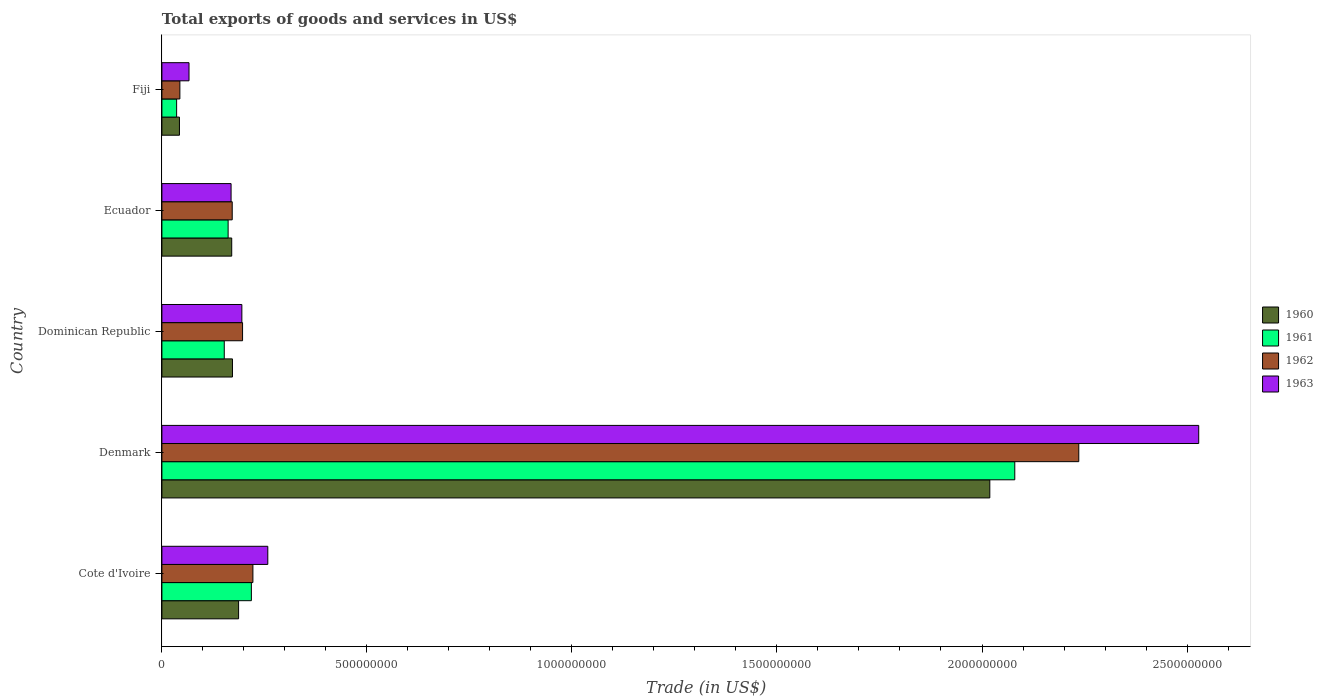What is the label of the 1st group of bars from the top?
Offer a terse response. Fiji. In how many cases, is the number of bars for a given country not equal to the number of legend labels?
Offer a terse response. 0. What is the total exports of goods and services in 1961 in Ecuador?
Your answer should be very brief. 1.61e+08. Across all countries, what is the maximum total exports of goods and services in 1962?
Give a very brief answer. 2.24e+09. Across all countries, what is the minimum total exports of goods and services in 1963?
Provide a short and direct response. 6.61e+07. In which country was the total exports of goods and services in 1961 maximum?
Your response must be concise. Denmark. In which country was the total exports of goods and services in 1960 minimum?
Make the answer very short. Fiji. What is the total total exports of goods and services in 1962 in the graph?
Offer a very short reply. 2.87e+09. What is the difference between the total exports of goods and services in 1963 in Denmark and that in Ecuador?
Keep it short and to the point. 2.36e+09. What is the difference between the total exports of goods and services in 1960 in Fiji and the total exports of goods and services in 1962 in Ecuador?
Provide a short and direct response. -1.29e+08. What is the average total exports of goods and services in 1960 per country?
Your answer should be compact. 5.18e+08. What is the difference between the total exports of goods and services in 1963 and total exports of goods and services in 1962 in Ecuador?
Give a very brief answer. -2.79e+06. In how many countries, is the total exports of goods and services in 1962 greater than 1200000000 US$?
Provide a short and direct response. 1. What is the ratio of the total exports of goods and services in 1960 in Denmark to that in Ecuador?
Make the answer very short. 11.86. Is the total exports of goods and services in 1963 in Cote d'Ivoire less than that in Dominican Republic?
Give a very brief answer. No. Is the difference between the total exports of goods and services in 1963 in Ecuador and Fiji greater than the difference between the total exports of goods and services in 1962 in Ecuador and Fiji?
Your answer should be very brief. No. What is the difference between the highest and the second highest total exports of goods and services in 1960?
Offer a terse response. 1.83e+09. What is the difference between the highest and the lowest total exports of goods and services in 1961?
Your answer should be very brief. 2.04e+09. What does the 3rd bar from the top in Dominican Republic represents?
Provide a succinct answer. 1961. Is it the case that in every country, the sum of the total exports of goods and services in 1963 and total exports of goods and services in 1961 is greater than the total exports of goods and services in 1960?
Ensure brevity in your answer.  Yes. What is the difference between two consecutive major ticks on the X-axis?
Your response must be concise. 5.00e+08. How many legend labels are there?
Keep it short and to the point. 4. How are the legend labels stacked?
Offer a terse response. Vertical. What is the title of the graph?
Your answer should be compact. Total exports of goods and services in US$. What is the label or title of the X-axis?
Ensure brevity in your answer.  Trade (in US$). What is the label or title of the Y-axis?
Your answer should be compact. Country. What is the Trade (in US$) of 1960 in Cote d'Ivoire?
Offer a very short reply. 1.87e+08. What is the Trade (in US$) in 1961 in Cote d'Ivoire?
Your answer should be compact. 2.18e+08. What is the Trade (in US$) in 1962 in Cote d'Ivoire?
Keep it short and to the point. 2.22e+08. What is the Trade (in US$) of 1963 in Cote d'Ivoire?
Offer a terse response. 2.58e+08. What is the Trade (in US$) in 1960 in Denmark?
Provide a short and direct response. 2.02e+09. What is the Trade (in US$) of 1961 in Denmark?
Ensure brevity in your answer.  2.08e+09. What is the Trade (in US$) in 1962 in Denmark?
Your answer should be compact. 2.24e+09. What is the Trade (in US$) in 1963 in Denmark?
Provide a short and direct response. 2.53e+09. What is the Trade (in US$) in 1960 in Dominican Republic?
Offer a terse response. 1.72e+08. What is the Trade (in US$) of 1961 in Dominican Republic?
Provide a short and direct response. 1.52e+08. What is the Trade (in US$) in 1962 in Dominican Republic?
Keep it short and to the point. 1.97e+08. What is the Trade (in US$) in 1963 in Dominican Republic?
Your answer should be compact. 1.95e+08. What is the Trade (in US$) of 1960 in Ecuador?
Make the answer very short. 1.70e+08. What is the Trade (in US$) of 1961 in Ecuador?
Offer a very short reply. 1.61e+08. What is the Trade (in US$) of 1962 in Ecuador?
Your response must be concise. 1.71e+08. What is the Trade (in US$) of 1963 in Ecuador?
Provide a short and direct response. 1.69e+08. What is the Trade (in US$) of 1960 in Fiji?
Your response must be concise. 4.28e+07. What is the Trade (in US$) in 1961 in Fiji?
Provide a succinct answer. 3.59e+07. What is the Trade (in US$) in 1962 in Fiji?
Give a very brief answer. 4.38e+07. What is the Trade (in US$) of 1963 in Fiji?
Your response must be concise. 6.61e+07. Across all countries, what is the maximum Trade (in US$) of 1960?
Give a very brief answer. 2.02e+09. Across all countries, what is the maximum Trade (in US$) in 1961?
Your response must be concise. 2.08e+09. Across all countries, what is the maximum Trade (in US$) of 1962?
Offer a very short reply. 2.24e+09. Across all countries, what is the maximum Trade (in US$) of 1963?
Provide a short and direct response. 2.53e+09. Across all countries, what is the minimum Trade (in US$) of 1960?
Provide a succinct answer. 4.28e+07. Across all countries, what is the minimum Trade (in US$) in 1961?
Make the answer very short. 3.59e+07. Across all countries, what is the minimum Trade (in US$) in 1962?
Keep it short and to the point. 4.38e+07. Across all countries, what is the minimum Trade (in US$) in 1963?
Make the answer very short. 6.61e+07. What is the total Trade (in US$) of 1960 in the graph?
Your response must be concise. 2.59e+09. What is the total Trade (in US$) in 1961 in the graph?
Give a very brief answer. 2.65e+09. What is the total Trade (in US$) in 1962 in the graph?
Provide a short and direct response. 2.87e+09. What is the total Trade (in US$) of 1963 in the graph?
Your answer should be compact. 3.22e+09. What is the difference between the Trade (in US$) in 1960 in Cote d'Ivoire and that in Denmark?
Make the answer very short. -1.83e+09. What is the difference between the Trade (in US$) in 1961 in Cote d'Ivoire and that in Denmark?
Provide a succinct answer. -1.86e+09. What is the difference between the Trade (in US$) of 1962 in Cote d'Ivoire and that in Denmark?
Your answer should be compact. -2.01e+09. What is the difference between the Trade (in US$) in 1963 in Cote d'Ivoire and that in Denmark?
Ensure brevity in your answer.  -2.27e+09. What is the difference between the Trade (in US$) of 1960 in Cote d'Ivoire and that in Dominican Republic?
Offer a terse response. 1.49e+07. What is the difference between the Trade (in US$) of 1961 in Cote d'Ivoire and that in Dominican Republic?
Keep it short and to the point. 6.61e+07. What is the difference between the Trade (in US$) in 1962 in Cote d'Ivoire and that in Dominican Republic?
Your answer should be compact. 2.52e+07. What is the difference between the Trade (in US$) of 1963 in Cote d'Ivoire and that in Dominican Republic?
Provide a short and direct response. 6.33e+07. What is the difference between the Trade (in US$) in 1960 in Cote d'Ivoire and that in Ecuador?
Offer a very short reply. 1.68e+07. What is the difference between the Trade (in US$) of 1961 in Cote d'Ivoire and that in Ecuador?
Provide a short and direct response. 5.67e+07. What is the difference between the Trade (in US$) in 1962 in Cote d'Ivoire and that in Ecuador?
Make the answer very short. 5.04e+07. What is the difference between the Trade (in US$) of 1963 in Cote d'Ivoire and that in Ecuador?
Your answer should be very brief. 8.96e+07. What is the difference between the Trade (in US$) of 1960 in Cote d'Ivoire and that in Fiji?
Give a very brief answer. 1.44e+08. What is the difference between the Trade (in US$) of 1961 in Cote d'Ivoire and that in Fiji?
Ensure brevity in your answer.  1.82e+08. What is the difference between the Trade (in US$) in 1962 in Cote d'Ivoire and that in Fiji?
Your response must be concise. 1.78e+08. What is the difference between the Trade (in US$) of 1963 in Cote d'Ivoire and that in Fiji?
Offer a very short reply. 1.92e+08. What is the difference between the Trade (in US$) of 1960 in Denmark and that in Dominican Republic?
Your answer should be very brief. 1.85e+09. What is the difference between the Trade (in US$) in 1961 in Denmark and that in Dominican Republic?
Offer a terse response. 1.93e+09. What is the difference between the Trade (in US$) of 1962 in Denmark and that in Dominican Republic?
Make the answer very short. 2.04e+09. What is the difference between the Trade (in US$) in 1963 in Denmark and that in Dominican Republic?
Provide a short and direct response. 2.33e+09. What is the difference between the Trade (in US$) in 1960 in Denmark and that in Ecuador?
Keep it short and to the point. 1.85e+09. What is the difference between the Trade (in US$) of 1961 in Denmark and that in Ecuador?
Your answer should be very brief. 1.92e+09. What is the difference between the Trade (in US$) in 1962 in Denmark and that in Ecuador?
Give a very brief answer. 2.06e+09. What is the difference between the Trade (in US$) of 1963 in Denmark and that in Ecuador?
Make the answer very short. 2.36e+09. What is the difference between the Trade (in US$) of 1960 in Denmark and that in Fiji?
Your answer should be compact. 1.98e+09. What is the difference between the Trade (in US$) of 1961 in Denmark and that in Fiji?
Provide a succinct answer. 2.04e+09. What is the difference between the Trade (in US$) in 1962 in Denmark and that in Fiji?
Your answer should be very brief. 2.19e+09. What is the difference between the Trade (in US$) in 1963 in Denmark and that in Fiji?
Ensure brevity in your answer.  2.46e+09. What is the difference between the Trade (in US$) of 1960 in Dominican Republic and that in Ecuador?
Ensure brevity in your answer.  1.84e+06. What is the difference between the Trade (in US$) in 1961 in Dominican Republic and that in Ecuador?
Offer a terse response. -9.39e+06. What is the difference between the Trade (in US$) in 1962 in Dominican Republic and that in Ecuador?
Make the answer very short. 2.52e+07. What is the difference between the Trade (in US$) in 1963 in Dominican Republic and that in Ecuador?
Give a very brief answer. 2.63e+07. What is the difference between the Trade (in US$) in 1960 in Dominican Republic and that in Fiji?
Provide a short and direct response. 1.29e+08. What is the difference between the Trade (in US$) in 1961 in Dominican Republic and that in Fiji?
Your answer should be very brief. 1.16e+08. What is the difference between the Trade (in US$) in 1962 in Dominican Republic and that in Fiji?
Ensure brevity in your answer.  1.53e+08. What is the difference between the Trade (in US$) of 1963 in Dominican Republic and that in Fiji?
Your response must be concise. 1.29e+08. What is the difference between the Trade (in US$) in 1960 in Ecuador and that in Fiji?
Keep it short and to the point. 1.27e+08. What is the difference between the Trade (in US$) in 1961 in Ecuador and that in Fiji?
Give a very brief answer. 1.26e+08. What is the difference between the Trade (in US$) of 1962 in Ecuador and that in Fiji?
Provide a short and direct response. 1.28e+08. What is the difference between the Trade (in US$) in 1963 in Ecuador and that in Fiji?
Your answer should be very brief. 1.03e+08. What is the difference between the Trade (in US$) of 1960 in Cote d'Ivoire and the Trade (in US$) of 1961 in Denmark?
Offer a very short reply. -1.89e+09. What is the difference between the Trade (in US$) of 1960 in Cote d'Ivoire and the Trade (in US$) of 1962 in Denmark?
Make the answer very short. -2.05e+09. What is the difference between the Trade (in US$) of 1960 in Cote d'Ivoire and the Trade (in US$) of 1963 in Denmark?
Your answer should be compact. -2.34e+09. What is the difference between the Trade (in US$) of 1961 in Cote d'Ivoire and the Trade (in US$) of 1962 in Denmark?
Your answer should be very brief. -2.02e+09. What is the difference between the Trade (in US$) of 1961 in Cote d'Ivoire and the Trade (in US$) of 1963 in Denmark?
Keep it short and to the point. -2.31e+09. What is the difference between the Trade (in US$) in 1962 in Cote d'Ivoire and the Trade (in US$) in 1963 in Denmark?
Offer a terse response. -2.31e+09. What is the difference between the Trade (in US$) in 1960 in Cote d'Ivoire and the Trade (in US$) in 1961 in Dominican Republic?
Make the answer very short. 3.49e+07. What is the difference between the Trade (in US$) in 1960 in Cote d'Ivoire and the Trade (in US$) in 1962 in Dominican Republic?
Your answer should be very brief. -9.68e+06. What is the difference between the Trade (in US$) in 1960 in Cote d'Ivoire and the Trade (in US$) in 1963 in Dominican Republic?
Offer a very short reply. -7.98e+06. What is the difference between the Trade (in US$) in 1961 in Cote d'Ivoire and the Trade (in US$) in 1962 in Dominican Republic?
Offer a very short reply. 2.15e+07. What is the difference between the Trade (in US$) of 1961 in Cote d'Ivoire and the Trade (in US$) of 1963 in Dominican Republic?
Make the answer very short. 2.32e+07. What is the difference between the Trade (in US$) of 1962 in Cote d'Ivoire and the Trade (in US$) of 1963 in Dominican Republic?
Provide a succinct answer. 2.69e+07. What is the difference between the Trade (in US$) in 1960 in Cote d'Ivoire and the Trade (in US$) in 1961 in Ecuador?
Give a very brief answer. 2.55e+07. What is the difference between the Trade (in US$) of 1960 in Cote d'Ivoire and the Trade (in US$) of 1962 in Ecuador?
Offer a very short reply. 1.55e+07. What is the difference between the Trade (in US$) of 1960 in Cote d'Ivoire and the Trade (in US$) of 1963 in Ecuador?
Keep it short and to the point. 1.83e+07. What is the difference between the Trade (in US$) of 1961 in Cote d'Ivoire and the Trade (in US$) of 1962 in Ecuador?
Your answer should be compact. 4.67e+07. What is the difference between the Trade (in US$) in 1961 in Cote d'Ivoire and the Trade (in US$) in 1963 in Ecuador?
Give a very brief answer. 4.95e+07. What is the difference between the Trade (in US$) in 1962 in Cote d'Ivoire and the Trade (in US$) in 1963 in Ecuador?
Your answer should be compact. 5.32e+07. What is the difference between the Trade (in US$) in 1960 in Cote d'Ivoire and the Trade (in US$) in 1961 in Fiji?
Give a very brief answer. 1.51e+08. What is the difference between the Trade (in US$) of 1960 in Cote d'Ivoire and the Trade (in US$) of 1962 in Fiji?
Offer a terse response. 1.43e+08. What is the difference between the Trade (in US$) in 1960 in Cote d'Ivoire and the Trade (in US$) in 1963 in Fiji?
Provide a short and direct response. 1.21e+08. What is the difference between the Trade (in US$) of 1961 in Cote d'Ivoire and the Trade (in US$) of 1962 in Fiji?
Keep it short and to the point. 1.74e+08. What is the difference between the Trade (in US$) in 1961 in Cote d'Ivoire and the Trade (in US$) in 1963 in Fiji?
Keep it short and to the point. 1.52e+08. What is the difference between the Trade (in US$) of 1962 in Cote d'Ivoire and the Trade (in US$) of 1963 in Fiji?
Offer a terse response. 1.56e+08. What is the difference between the Trade (in US$) of 1960 in Denmark and the Trade (in US$) of 1961 in Dominican Republic?
Your response must be concise. 1.87e+09. What is the difference between the Trade (in US$) in 1960 in Denmark and the Trade (in US$) in 1962 in Dominican Republic?
Make the answer very short. 1.82e+09. What is the difference between the Trade (in US$) of 1960 in Denmark and the Trade (in US$) of 1963 in Dominican Republic?
Make the answer very short. 1.82e+09. What is the difference between the Trade (in US$) of 1961 in Denmark and the Trade (in US$) of 1962 in Dominican Republic?
Keep it short and to the point. 1.88e+09. What is the difference between the Trade (in US$) in 1961 in Denmark and the Trade (in US$) in 1963 in Dominican Republic?
Provide a succinct answer. 1.88e+09. What is the difference between the Trade (in US$) of 1962 in Denmark and the Trade (in US$) of 1963 in Dominican Republic?
Your answer should be very brief. 2.04e+09. What is the difference between the Trade (in US$) in 1960 in Denmark and the Trade (in US$) in 1961 in Ecuador?
Give a very brief answer. 1.86e+09. What is the difference between the Trade (in US$) in 1960 in Denmark and the Trade (in US$) in 1962 in Ecuador?
Provide a succinct answer. 1.85e+09. What is the difference between the Trade (in US$) in 1960 in Denmark and the Trade (in US$) in 1963 in Ecuador?
Your answer should be compact. 1.85e+09. What is the difference between the Trade (in US$) of 1961 in Denmark and the Trade (in US$) of 1962 in Ecuador?
Your answer should be compact. 1.91e+09. What is the difference between the Trade (in US$) of 1961 in Denmark and the Trade (in US$) of 1963 in Ecuador?
Give a very brief answer. 1.91e+09. What is the difference between the Trade (in US$) in 1962 in Denmark and the Trade (in US$) in 1963 in Ecuador?
Ensure brevity in your answer.  2.07e+09. What is the difference between the Trade (in US$) of 1960 in Denmark and the Trade (in US$) of 1961 in Fiji?
Keep it short and to the point. 1.98e+09. What is the difference between the Trade (in US$) of 1960 in Denmark and the Trade (in US$) of 1962 in Fiji?
Your answer should be very brief. 1.98e+09. What is the difference between the Trade (in US$) in 1960 in Denmark and the Trade (in US$) in 1963 in Fiji?
Provide a succinct answer. 1.95e+09. What is the difference between the Trade (in US$) in 1961 in Denmark and the Trade (in US$) in 1962 in Fiji?
Ensure brevity in your answer.  2.04e+09. What is the difference between the Trade (in US$) of 1961 in Denmark and the Trade (in US$) of 1963 in Fiji?
Give a very brief answer. 2.01e+09. What is the difference between the Trade (in US$) of 1962 in Denmark and the Trade (in US$) of 1963 in Fiji?
Make the answer very short. 2.17e+09. What is the difference between the Trade (in US$) of 1960 in Dominican Republic and the Trade (in US$) of 1961 in Ecuador?
Ensure brevity in your answer.  1.06e+07. What is the difference between the Trade (in US$) of 1960 in Dominican Republic and the Trade (in US$) of 1962 in Ecuador?
Provide a short and direct response. 6.09e+05. What is the difference between the Trade (in US$) in 1960 in Dominican Republic and the Trade (in US$) in 1963 in Ecuador?
Give a very brief answer. 3.40e+06. What is the difference between the Trade (in US$) of 1961 in Dominican Republic and the Trade (in US$) of 1962 in Ecuador?
Offer a terse response. -1.94e+07. What is the difference between the Trade (in US$) in 1961 in Dominican Republic and the Trade (in US$) in 1963 in Ecuador?
Your answer should be very brief. -1.66e+07. What is the difference between the Trade (in US$) in 1962 in Dominican Republic and the Trade (in US$) in 1963 in Ecuador?
Your answer should be compact. 2.80e+07. What is the difference between the Trade (in US$) of 1960 in Dominican Republic and the Trade (in US$) of 1961 in Fiji?
Your response must be concise. 1.36e+08. What is the difference between the Trade (in US$) of 1960 in Dominican Republic and the Trade (in US$) of 1962 in Fiji?
Ensure brevity in your answer.  1.28e+08. What is the difference between the Trade (in US$) of 1960 in Dominican Republic and the Trade (in US$) of 1963 in Fiji?
Provide a succinct answer. 1.06e+08. What is the difference between the Trade (in US$) in 1961 in Dominican Republic and the Trade (in US$) in 1962 in Fiji?
Make the answer very short. 1.08e+08. What is the difference between the Trade (in US$) in 1961 in Dominican Republic and the Trade (in US$) in 1963 in Fiji?
Your response must be concise. 8.60e+07. What is the difference between the Trade (in US$) of 1962 in Dominican Republic and the Trade (in US$) of 1963 in Fiji?
Offer a terse response. 1.31e+08. What is the difference between the Trade (in US$) of 1960 in Ecuador and the Trade (in US$) of 1961 in Fiji?
Your response must be concise. 1.34e+08. What is the difference between the Trade (in US$) of 1960 in Ecuador and the Trade (in US$) of 1962 in Fiji?
Your answer should be compact. 1.26e+08. What is the difference between the Trade (in US$) of 1960 in Ecuador and the Trade (in US$) of 1963 in Fiji?
Your answer should be compact. 1.04e+08. What is the difference between the Trade (in US$) of 1961 in Ecuador and the Trade (in US$) of 1962 in Fiji?
Your answer should be compact. 1.18e+08. What is the difference between the Trade (in US$) in 1961 in Ecuador and the Trade (in US$) in 1963 in Fiji?
Your response must be concise. 9.54e+07. What is the difference between the Trade (in US$) of 1962 in Ecuador and the Trade (in US$) of 1963 in Fiji?
Provide a short and direct response. 1.05e+08. What is the average Trade (in US$) in 1960 per country?
Your answer should be very brief. 5.18e+08. What is the average Trade (in US$) in 1961 per country?
Your answer should be very brief. 5.30e+08. What is the average Trade (in US$) in 1962 per country?
Ensure brevity in your answer.  5.74e+08. What is the average Trade (in US$) in 1963 per country?
Offer a very short reply. 6.43e+08. What is the difference between the Trade (in US$) of 1960 and Trade (in US$) of 1961 in Cote d'Ivoire?
Offer a very short reply. -3.12e+07. What is the difference between the Trade (in US$) in 1960 and Trade (in US$) in 1962 in Cote d'Ivoire?
Provide a short and direct response. -3.49e+07. What is the difference between the Trade (in US$) of 1960 and Trade (in US$) of 1963 in Cote d'Ivoire?
Keep it short and to the point. -7.12e+07. What is the difference between the Trade (in US$) in 1961 and Trade (in US$) in 1962 in Cote d'Ivoire?
Keep it short and to the point. -3.74e+06. What is the difference between the Trade (in US$) in 1961 and Trade (in US$) in 1963 in Cote d'Ivoire?
Offer a terse response. -4.01e+07. What is the difference between the Trade (in US$) of 1962 and Trade (in US$) of 1963 in Cote d'Ivoire?
Provide a succinct answer. -3.63e+07. What is the difference between the Trade (in US$) of 1960 and Trade (in US$) of 1961 in Denmark?
Provide a succinct answer. -6.09e+07. What is the difference between the Trade (in US$) of 1960 and Trade (in US$) of 1962 in Denmark?
Your response must be concise. -2.17e+08. What is the difference between the Trade (in US$) of 1960 and Trade (in US$) of 1963 in Denmark?
Your answer should be compact. -5.09e+08. What is the difference between the Trade (in US$) of 1961 and Trade (in US$) of 1962 in Denmark?
Make the answer very short. -1.56e+08. What is the difference between the Trade (in US$) in 1961 and Trade (in US$) in 1963 in Denmark?
Provide a succinct answer. -4.49e+08. What is the difference between the Trade (in US$) of 1962 and Trade (in US$) of 1963 in Denmark?
Provide a short and direct response. -2.92e+08. What is the difference between the Trade (in US$) of 1960 and Trade (in US$) of 1961 in Dominican Republic?
Your answer should be very brief. 2.00e+07. What is the difference between the Trade (in US$) of 1960 and Trade (in US$) of 1962 in Dominican Republic?
Your answer should be very brief. -2.46e+07. What is the difference between the Trade (in US$) in 1960 and Trade (in US$) in 1963 in Dominican Republic?
Your response must be concise. -2.29e+07. What is the difference between the Trade (in US$) of 1961 and Trade (in US$) of 1962 in Dominican Republic?
Give a very brief answer. -4.46e+07. What is the difference between the Trade (in US$) in 1961 and Trade (in US$) in 1963 in Dominican Republic?
Your answer should be very brief. -4.29e+07. What is the difference between the Trade (in US$) in 1962 and Trade (in US$) in 1963 in Dominican Republic?
Provide a succinct answer. 1.70e+06. What is the difference between the Trade (in US$) of 1960 and Trade (in US$) of 1961 in Ecuador?
Provide a succinct answer. 8.78e+06. What is the difference between the Trade (in US$) in 1960 and Trade (in US$) in 1962 in Ecuador?
Provide a short and direct response. -1.23e+06. What is the difference between the Trade (in US$) in 1960 and Trade (in US$) in 1963 in Ecuador?
Offer a terse response. 1.56e+06. What is the difference between the Trade (in US$) in 1961 and Trade (in US$) in 1962 in Ecuador?
Give a very brief answer. -1.00e+07. What is the difference between the Trade (in US$) of 1961 and Trade (in US$) of 1963 in Ecuador?
Your response must be concise. -7.21e+06. What is the difference between the Trade (in US$) in 1962 and Trade (in US$) in 1963 in Ecuador?
Make the answer very short. 2.79e+06. What is the difference between the Trade (in US$) in 1960 and Trade (in US$) in 1961 in Fiji?
Ensure brevity in your answer.  6.93e+06. What is the difference between the Trade (in US$) in 1960 and Trade (in US$) in 1962 in Fiji?
Provide a short and direct response. -1.01e+06. What is the difference between the Trade (in US$) in 1960 and Trade (in US$) in 1963 in Fiji?
Provide a succinct answer. -2.33e+07. What is the difference between the Trade (in US$) of 1961 and Trade (in US$) of 1962 in Fiji?
Provide a succinct answer. -7.93e+06. What is the difference between the Trade (in US$) in 1961 and Trade (in US$) in 1963 in Fiji?
Ensure brevity in your answer.  -3.02e+07. What is the difference between the Trade (in US$) in 1962 and Trade (in US$) in 1963 in Fiji?
Your answer should be compact. -2.23e+07. What is the ratio of the Trade (in US$) in 1960 in Cote d'Ivoire to that in Denmark?
Ensure brevity in your answer.  0.09. What is the ratio of the Trade (in US$) of 1961 in Cote d'Ivoire to that in Denmark?
Offer a very short reply. 0.1. What is the ratio of the Trade (in US$) in 1962 in Cote d'Ivoire to that in Denmark?
Your answer should be very brief. 0.1. What is the ratio of the Trade (in US$) of 1963 in Cote d'Ivoire to that in Denmark?
Provide a succinct answer. 0.1. What is the ratio of the Trade (in US$) in 1960 in Cote d'Ivoire to that in Dominican Republic?
Ensure brevity in your answer.  1.09. What is the ratio of the Trade (in US$) in 1961 in Cote d'Ivoire to that in Dominican Republic?
Ensure brevity in your answer.  1.43. What is the ratio of the Trade (in US$) of 1962 in Cote d'Ivoire to that in Dominican Republic?
Provide a short and direct response. 1.13. What is the ratio of the Trade (in US$) of 1963 in Cote d'Ivoire to that in Dominican Republic?
Give a very brief answer. 1.32. What is the ratio of the Trade (in US$) in 1960 in Cote d'Ivoire to that in Ecuador?
Ensure brevity in your answer.  1.1. What is the ratio of the Trade (in US$) of 1961 in Cote d'Ivoire to that in Ecuador?
Give a very brief answer. 1.35. What is the ratio of the Trade (in US$) of 1962 in Cote d'Ivoire to that in Ecuador?
Your response must be concise. 1.29. What is the ratio of the Trade (in US$) in 1963 in Cote d'Ivoire to that in Ecuador?
Your answer should be compact. 1.53. What is the ratio of the Trade (in US$) in 1960 in Cote d'Ivoire to that in Fiji?
Make the answer very short. 4.37. What is the ratio of the Trade (in US$) of 1961 in Cote d'Ivoire to that in Fiji?
Provide a succinct answer. 6.08. What is the ratio of the Trade (in US$) of 1962 in Cote d'Ivoire to that in Fiji?
Give a very brief answer. 5.06. What is the ratio of the Trade (in US$) in 1963 in Cote d'Ivoire to that in Fiji?
Your answer should be compact. 3.91. What is the ratio of the Trade (in US$) of 1960 in Denmark to that in Dominican Republic?
Your answer should be very brief. 11.73. What is the ratio of the Trade (in US$) of 1961 in Denmark to that in Dominican Republic?
Your response must be concise. 13.67. What is the ratio of the Trade (in US$) in 1962 in Denmark to that in Dominican Republic?
Provide a short and direct response. 11.37. What is the ratio of the Trade (in US$) in 1963 in Denmark to that in Dominican Republic?
Your answer should be very brief. 12.97. What is the ratio of the Trade (in US$) in 1960 in Denmark to that in Ecuador?
Your answer should be compact. 11.86. What is the ratio of the Trade (in US$) in 1961 in Denmark to that in Ecuador?
Your response must be concise. 12.88. What is the ratio of the Trade (in US$) in 1962 in Denmark to that in Ecuador?
Keep it short and to the point. 13.04. What is the ratio of the Trade (in US$) in 1963 in Denmark to that in Ecuador?
Your response must be concise. 14.99. What is the ratio of the Trade (in US$) of 1960 in Denmark to that in Fiji?
Give a very brief answer. 47.15. What is the ratio of the Trade (in US$) in 1961 in Denmark to that in Fiji?
Your response must be concise. 57.95. What is the ratio of the Trade (in US$) in 1962 in Denmark to that in Fiji?
Offer a terse response. 51.02. What is the ratio of the Trade (in US$) in 1963 in Denmark to that in Fiji?
Offer a terse response. 38.24. What is the ratio of the Trade (in US$) of 1960 in Dominican Republic to that in Ecuador?
Your response must be concise. 1.01. What is the ratio of the Trade (in US$) of 1961 in Dominican Republic to that in Ecuador?
Your response must be concise. 0.94. What is the ratio of the Trade (in US$) of 1962 in Dominican Republic to that in Ecuador?
Offer a very short reply. 1.15. What is the ratio of the Trade (in US$) in 1963 in Dominican Republic to that in Ecuador?
Ensure brevity in your answer.  1.16. What is the ratio of the Trade (in US$) in 1960 in Dominican Republic to that in Fiji?
Offer a terse response. 4.02. What is the ratio of the Trade (in US$) in 1961 in Dominican Republic to that in Fiji?
Offer a terse response. 4.24. What is the ratio of the Trade (in US$) in 1962 in Dominican Republic to that in Fiji?
Offer a terse response. 4.49. What is the ratio of the Trade (in US$) in 1963 in Dominican Republic to that in Fiji?
Give a very brief answer. 2.95. What is the ratio of the Trade (in US$) in 1960 in Ecuador to that in Fiji?
Your response must be concise. 3.98. What is the ratio of the Trade (in US$) in 1961 in Ecuador to that in Fiji?
Provide a succinct answer. 4.5. What is the ratio of the Trade (in US$) in 1962 in Ecuador to that in Fiji?
Give a very brief answer. 3.91. What is the ratio of the Trade (in US$) of 1963 in Ecuador to that in Fiji?
Your answer should be compact. 2.55. What is the difference between the highest and the second highest Trade (in US$) of 1960?
Your response must be concise. 1.83e+09. What is the difference between the highest and the second highest Trade (in US$) of 1961?
Offer a very short reply. 1.86e+09. What is the difference between the highest and the second highest Trade (in US$) of 1962?
Give a very brief answer. 2.01e+09. What is the difference between the highest and the second highest Trade (in US$) of 1963?
Ensure brevity in your answer.  2.27e+09. What is the difference between the highest and the lowest Trade (in US$) of 1960?
Your answer should be very brief. 1.98e+09. What is the difference between the highest and the lowest Trade (in US$) in 1961?
Provide a succinct answer. 2.04e+09. What is the difference between the highest and the lowest Trade (in US$) of 1962?
Your response must be concise. 2.19e+09. What is the difference between the highest and the lowest Trade (in US$) of 1963?
Provide a short and direct response. 2.46e+09. 